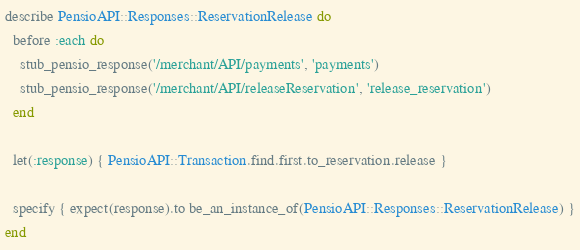<code> <loc_0><loc_0><loc_500><loc_500><_Ruby_>
describe PensioAPI::Responses::ReservationRelease do
  before :each do
    stub_pensio_response('/merchant/API/payments', 'payments')
    stub_pensio_response('/merchant/API/releaseReservation', 'release_reservation')
  end

  let(:response) { PensioAPI::Transaction.find.first.to_reservation.release }

  specify { expect(response).to be_an_instance_of(PensioAPI::Responses::ReservationRelease) }
end
</code> 